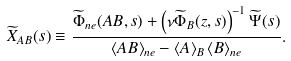<formula> <loc_0><loc_0><loc_500><loc_500>\widetilde { X } _ { A B } ( s ) \equiv \frac { \widetilde { \Phi } _ { n e } ( A B , s ) + \left ( \nu \widetilde { \Phi } _ { B } ( z , s ) \right ) ^ { - 1 } \widetilde { \Psi } ( s ) } { \left \langle A B \right \rangle _ { n e } - \left \langle A \right \rangle _ { B } \left \langle B \right \rangle _ { n e } } .</formula> 